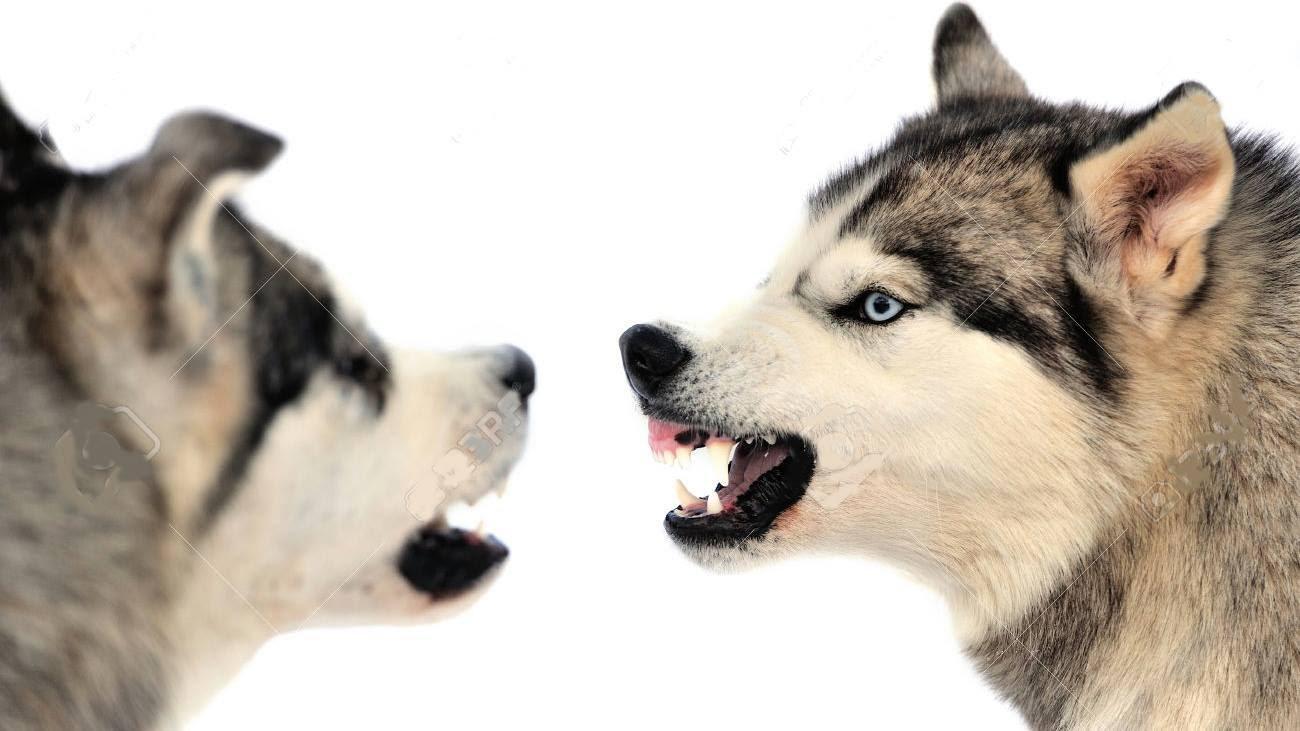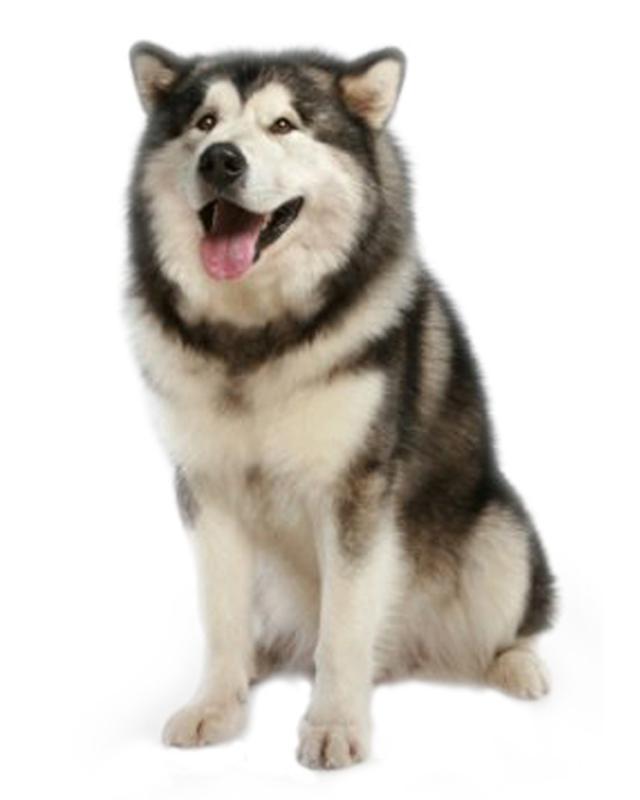The first image is the image on the left, the second image is the image on the right. For the images displayed, is the sentence "In one image there is one dog, and in the other image there are two dogs that are the same breed." factually correct? Answer yes or no. Yes. The first image is the image on the left, the second image is the image on the right. Assess this claim about the two images: "The combined images include three husky dogs that are standing up and at least two dogs with their tongues hanging out of smiling mouths.". Correct or not? Answer yes or no. No. 